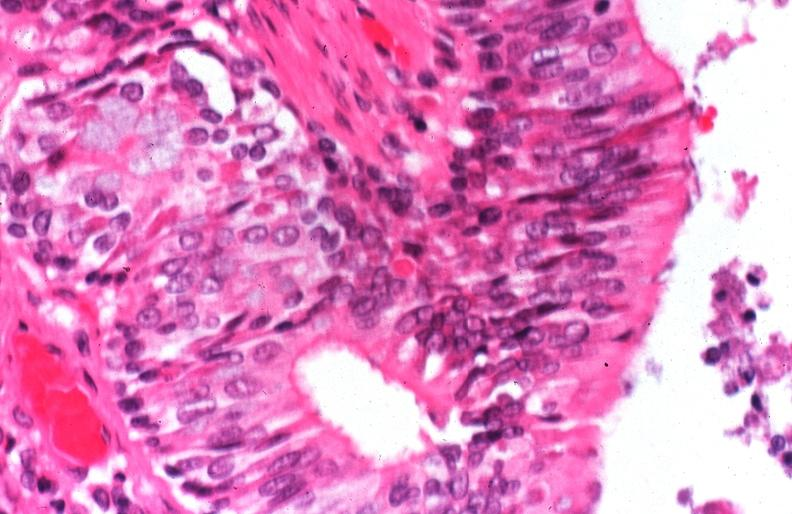does hematoma show lung, cystic fibrosis?
Answer the question using a single word or phrase. No 